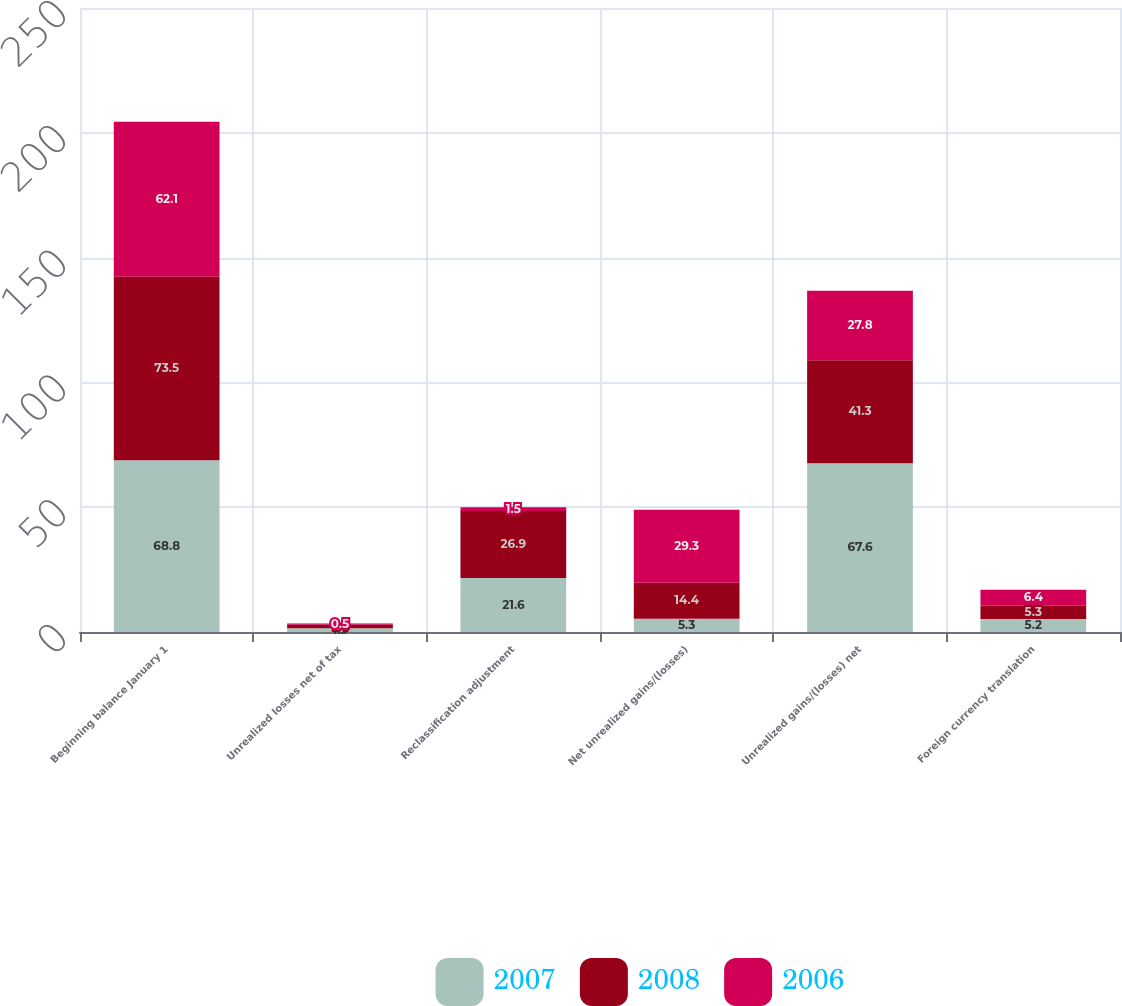Convert chart to OTSL. <chart><loc_0><loc_0><loc_500><loc_500><stacked_bar_chart><ecel><fcel>Beginning balance January 1<fcel>Unrealized losses net of tax<fcel>Reclassification adjustment<fcel>Net unrealized gains/(losses)<fcel>Unrealized gains/(losses) net<fcel>Foreign currency translation<nl><fcel>2007<fcel>68.8<fcel>1.5<fcel>21.6<fcel>5.3<fcel>67.6<fcel>5.2<nl><fcel>2008<fcel>73.5<fcel>1.4<fcel>26.9<fcel>14.4<fcel>41.3<fcel>5.3<nl><fcel>2006<fcel>62.1<fcel>0.5<fcel>1.5<fcel>29.3<fcel>27.8<fcel>6.4<nl></chart> 